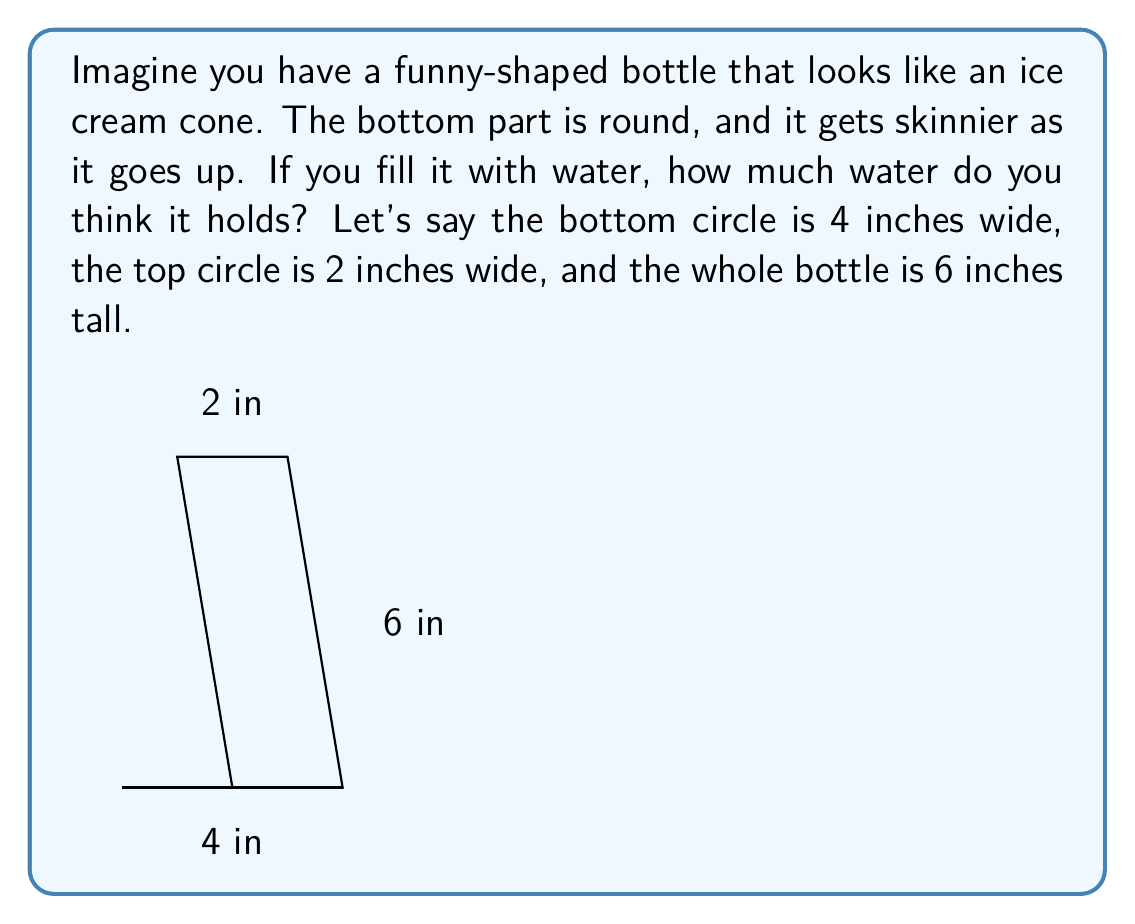Help me with this question. Let's break this down into simple steps:

1. The bottle looks like a cone, but upside down. We can use a special formula for this shape.

2. The formula for the volume of a cone is:
   $$V = \frac{1}{3} \pi r^2 h$$
   Where $r$ is the radius of the bottom circle, and $h$ is the height.

3. We know:
   - The bottom circle is 4 inches wide, so its radius is 2 inches
   - The height is 6 inches

4. Let's put these numbers into our formula:
   $$V = \frac{1}{3} \pi (2)^2 (6)$$

5. Now, let's solve it step by step:
   $$V = \frac{1}{3} \pi (4) (6)$$
   $$V = \frac{1}{3} \pi (24)$$
   $$V = 8\pi$$

6. $8\pi$ is about 25.13 cubic inches.

So, the funny-shaped bottle holds about 25 cubic inches of water!
Answer: 25 cubic inches 